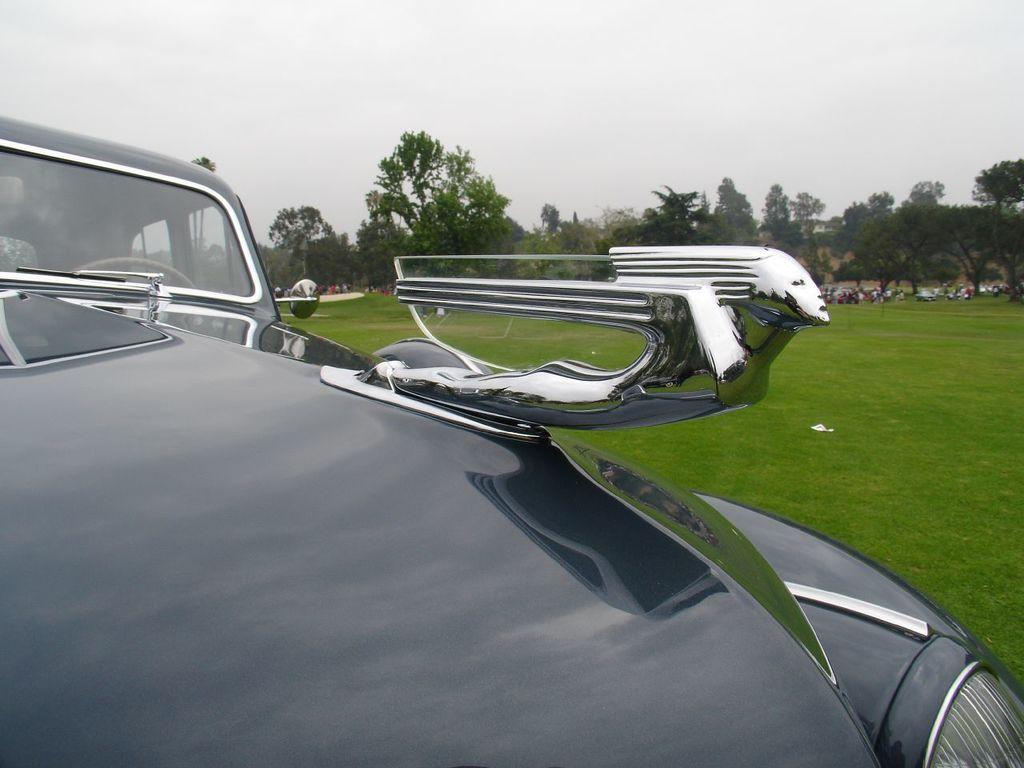In one or two sentences, can you explain what this image depicts? In this image we can see a vehicle and there are some people and we can see the grass on the ground. There are some trees in the background and at the top we can see the sky. 